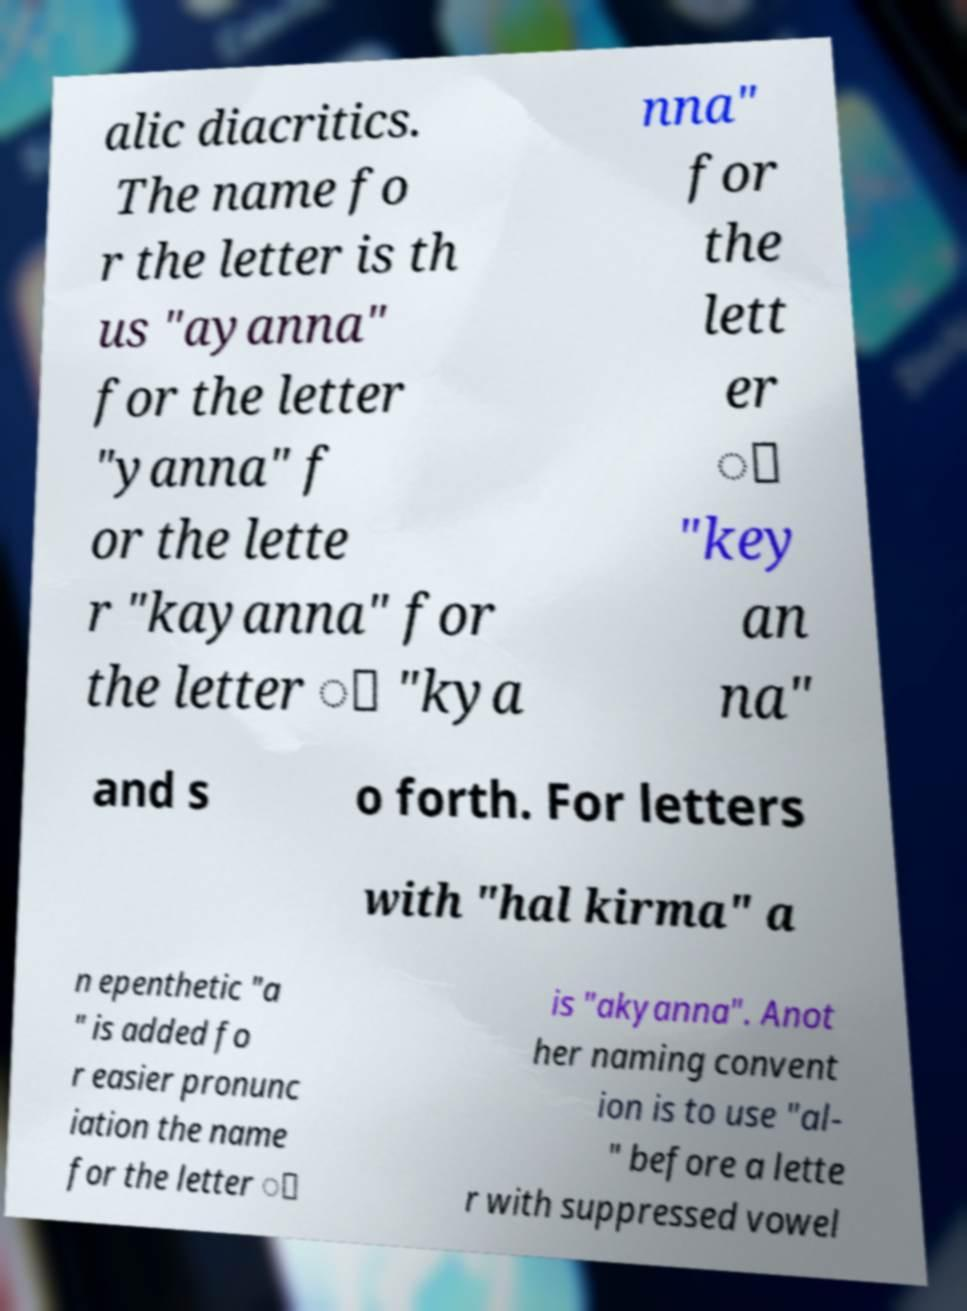Can you accurately transcribe the text from the provided image for me? alic diacritics. The name fo r the letter is th us "ayanna" for the letter "yanna" f or the lette r "kayanna" for the letter ා "kya nna" for the lett er ෙ "key an na" and s o forth. For letters with "hal kirma" a n epenthetic "a " is added fo r easier pronunc iation the name for the letter ් is "akyanna". Anot her naming convent ion is to use "al- " before a lette r with suppressed vowel 